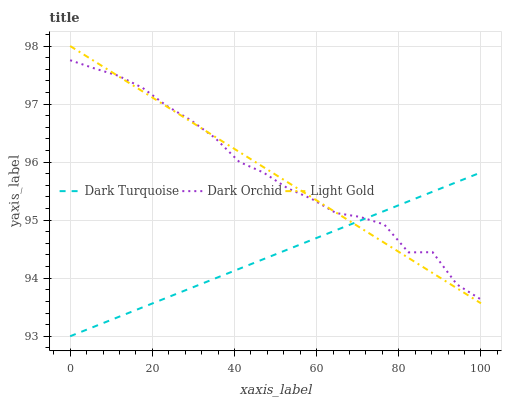Does Dark Turquoise have the minimum area under the curve?
Answer yes or no. Yes. Does Dark Orchid have the maximum area under the curve?
Answer yes or no. Yes. Does Light Gold have the minimum area under the curve?
Answer yes or no. No. Does Light Gold have the maximum area under the curve?
Answer yes or no. No. Is Dark Turquoise the smoothest?
Answer yes or no. Yes. Is Dark Orchid the roughest?
Answer yes or no. Yes. Is Light Gold the smoothest?
Answer yes or no. No. Is Light Gold the roughest?
Answer yes or no. No. Does Light Gold have the lowest value?
Answer yes or no. No. Does Dark Orchid have the highest value?
Answer yes or no. No. 